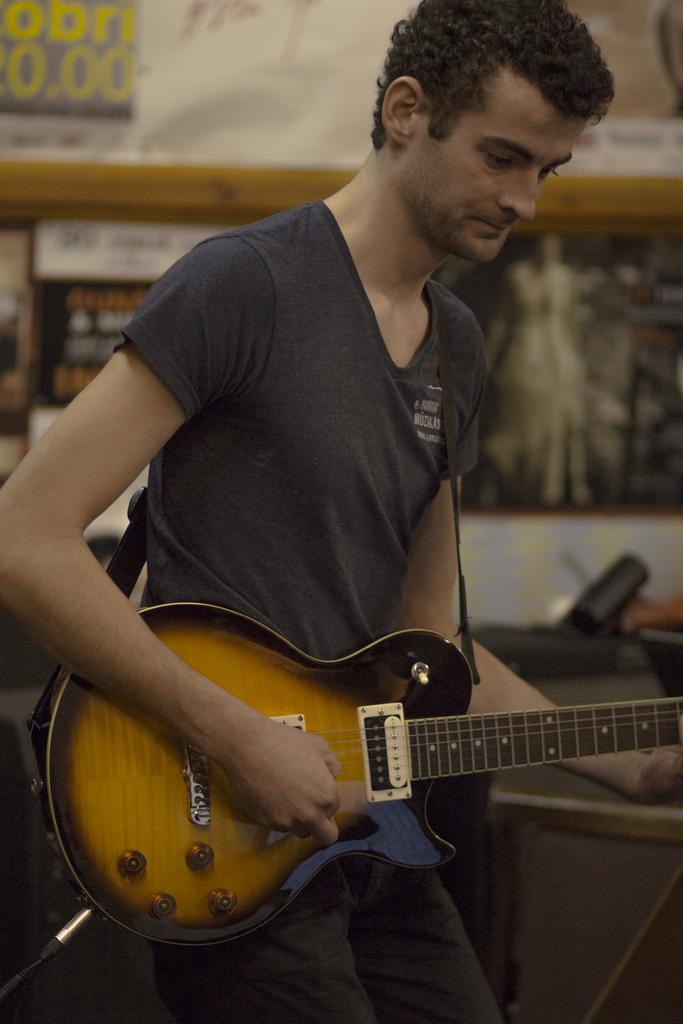What is the main subject of the image? There is a person in the image. What is the person wearing? The person is wearing a black color shirt. What is the person doing in the image? The person is playing a guitar. Can you see any cows in the image? No, there are no cows present in the image. What type of veil is the person wearing in the image? There is no veil present in the image; the person is wearing a black color shirt. 